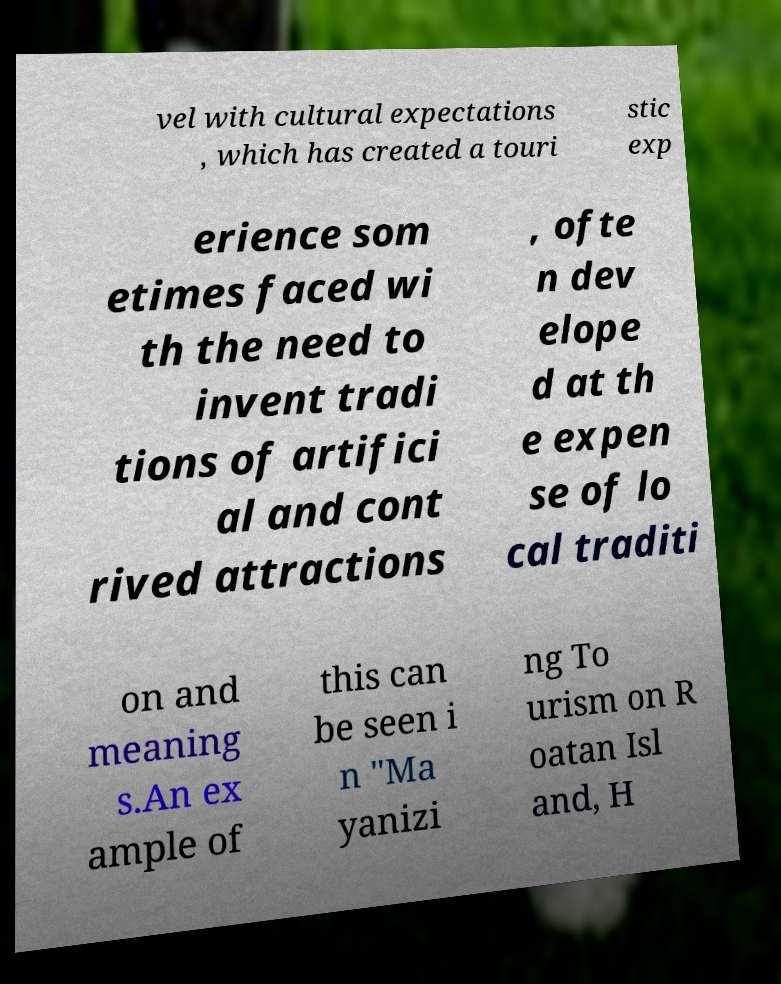There's text embedded in this image that I need extracted. Can you transcribe it verbatim? vel with cultural expectations , which has created a touri stic exp erience som etimes faced wi th the need to invent tradi tions of artifici al and cont rived attractions , ofte n dev elope d at th e expen se of lo cal traditi on and meaning s.An ex ample of this can be seen i n "Ma yanizi ng To urism on R oatan Isl and, H 